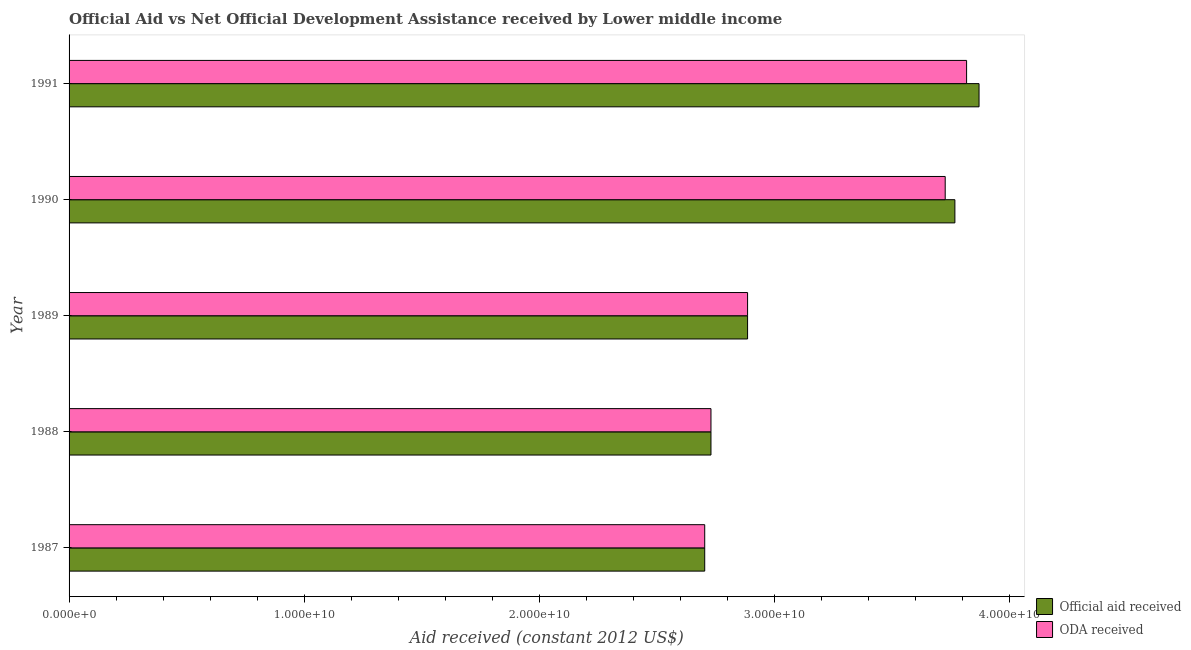How many different coloured bars are there?
Keep it short and to the point. 2. How many groups of bars are there?
Offer a terse response. 5. How many bars are there on the 1st tick from the bottom?
Your answer should be very brief. 2. What is the label of the 1st group of bars from the top?
Give a very brief answer. 1991. In how many cases, is the number of bars for a given year not equal to the number of legend labels?
Ensure brevity in your answer.  0. What is the oda received in 1989?
Your answer should be very brief. 2.89e+1. Across all years, what is the maximum official aid received?
Provide a short and direct response. 3.87e+1. Across all years, what is the minimum official aid received?
Your answer should be very brief. 2.70e+1. In which year was the oda received maximum?
Offer a very short reply. 1991. In which year was the official aid received minimum?
Provide a short and direct response. 1987. What is the total oda received in the graph?
Give a very brief answer. 1.59e+11. What is the difference between the oda received in 1987 and that in 1990?
Your answer should be compact. -1.02e+1. What is the difference between the official aid received in 1990 and the oda received in 1991?
Your answer should be very brief. -4.98e+08. What is the average oda received per year?
Your response must be concise. 3.17e+1. In the year 1988, what is the difference between the official aid received and oda received?
Make the answer very short. 0. What is the ratio of the oda received in 1989 to that in 1990?
Your response must be concise. 0.77. Is the official aid received in 1989 less than that in 1990?
Offer a very short reply. Yes. What is the difference between the highest and the second highest oda received?
Give a very brief answer. 9.10e+08. What is the difference between the highest and the lowest official aid received?
Make the answer very short. 1.17e+1. What does the 2nd bar from the top in 1990 represents?
Your response must be concise. Official aid received. What does the 2nd bar from the bottom in 1989 represents?
Make the answer very short. ODA received. Are all the bars in the graph horizontal?
Ensure brevity in your answer.  Yes. How many years are there in the graph?
Give a very brief answer. 5. What is the difference between two consecutive major ticks on the X-axis?
Your answer should be compact. 1.00e+1. Are the values on the major ticks of X-axis written in scientific E-notation?
Make the answer very short. Yes. Does the graph contain any zero values?
Give a very brief answer. No. How many legend labels are there?
Provide a succinct answer. 2. What is the title of the graph?
Your answer should be compact. Official Aid vs Net Official Development Assistance received by Lower middle income . What is the label or title of the X-axis?
Your answer should be very brief. Aid received (constant 2012 US$). What is the label or title of the Y-axis?
Make the answer very short. Year. What is the Aid received (constant 2012 US$) of Official aid received in 1987?
Ensure brevity in your answer.  2.70e+1. What is the Aid received (constant 2012 US$) in ODA received in 1987?
Your answer should be compact. 2.70e+1. What is the Aid received (constant 2012 US$) of Official aid received in 1988?
Your answer should be compact. 2.73e+1. What is the Aid received (constant 2012 US$) in ODA received in 1988?
Ensure brevity in your answer.  2.73e+1. What is the Aid received (constant 2012 US$) of Official aid received in 1989?
Provide a short and direct response. 2.89e+1. What is the Aid received (constant 2012 US$) in ODA received in 1989?
Your answer should be very brief. 2.89e+1. What is the Aid received (constant 2012 US$) in Official aid received in 1990?
Your answer should be very brief. 3.77e+1. What is the Aid received (constant 2012 US$) in ODA received in 1990?
Provide a short and direct response. 3.73e+1. What is the Aid received (constant 2012 US$) of Official aid received in 1991?
Offer a terse response. 3.87e+1. What is the Aid received (constant 2012 US$) in ODA received in 1991?
Offer a very short reply. 3.82e+1. Across all years, what is the maximum Aid received (constant 2012 US$) of Official aid received?
Give a very brief answer. 3.87e+1. Across all years, what is the maximum Aid received (constant 2012 US$) of ODA received?
Make the answer very short. 3.82e+1. Across all years, what is the minimum Aid received (constant 2012 US$) of Official aid received?
Your answer should be very brief. 2.70e+1. Across all years, what is the minimum Aid received (constant 2012 US$) in ODA received?
Provide a succinct answer. 2.70e+1. What is the total Aid received (constant 2012 US$) in Official aid received in the graph?
Provide a succinct answer. 1.60e+11. What is the total Aid received (constant 2012 US$) of ODA received in the graph?
Your response must be concise. 1.59e+11. What is the difference between the Aid received (constant 2012 US$) in Official aid received in 1987 and that in 1988?
Offer a terse response. -2.65e+08. What is the difference between the Aid received (constant 2012 US$) of ODA received in 1987 and that in 1988?
Your response must be concise. -2.65e+08. What is the difference between the Aid received (constant 2012 US$) of Official aid received in 1987 and that in 1989?
Give a very brief answer. -1.82e+09. What is the difference between the Aid received (constant 2012 US$) in ODA received in 1987 and that in 1989?
Offer a terse response. -1.82e+09. What is the difference between the Aid received (constant 2012 US$) in Official aid received in 1987 and that in 1990?
Make the answer very short. -1.06e+1. What is the difference between the Aid received (constant 2012 US$) of ODA received in 1987 and that in 1990?
Make the answer very short. -1.02e+1. What is the difference between the Aid received (constant 2012 US$) of Official aid received in 1987 and that in 1991?
Keep it short and to the point. -1.17e+1. What is the difference between the Aid received (constant 2012 US$) in ODA received in 1987 and that in 1991?
Offer a terse response. -1.11e+1. What is the difference between the Aid received (constant 2012 US$) in Official aid received in 1988 and that in 1989?
Offer a very short reply. -1.56e+09. What is the difference between the Aid received (constant 2012 US$) in ODA received in 1988 and that in 1989?
Provide a succinct answer. -1.56e+09. What is the difference between the Aid received (constant 2012 US$) of Official aid received in 1988 and that in 1990?
Offer a terse response. -1.04e+1. What is the difference between the Aid received (constant 2012 US$) in ODA received in 1988 and that in 1990?
Provide a short and direct response. -9.97e+09. What is the difference between the Aid received (constant 2012 US$) in Official aid received in 1988 and that in 1991?
Keep it short and to the point. -1.14e+1. What is the difference between the Aid received (constant 2012 US$) of ODA received in 1988 and that in 1991?
Offer a terse response. -1.09e+1. What is the difference between the Aid received (constant 2012 US$) of Official aid received in 1989 and that in 1990?
Ensure brevity in your answer.  -8.82e+09. What is the difference between the Aid received (constant 2012 US$) of ODA received in 1989 and that in 1990?
Give a very brief answer. -8.41e+09. What is the difference between the Aid received (constant 2012 US$) of Official aid received in 1989 and that in 1991?
Ensure brevity in your answer.  -9.85e+09. What is the difference between the Aid received (constant 2012 US$) in ODA received in 1989 and that in 1991?
Your answer should be very brief. -9.32e+09. What is the difference between the Aid received (constant 2012 US$) in Official aid received in 1990 and that in 1991?
Your answer should be compact. -1.03e+09. What is the difference between the Aid received (constant 2012 US$) of ODA received in 1990 and that in 1991?
Provide a succinct answer. -9.10e+08. What is the difference between the Aid received (constant 2012 US$) in Official aid received in 1987 and the Aid received (constant 2012 US$) in ODA received in 1988?
Offer a very short reply. -2.65e+08. What is the difference between the Aid received (constant 2012 US$) in Official aid received in 1987 and the Aid received (constant 2012 US$) in ODA received in 1989?
Keep it short and to the point. -1.82e+09. What is the difference between the Aid received (constant 2012 US$) in Official aid received in 1987 and the Aid received (constant 2012 US$) in ODA received in 1990?
Offer a terse response. -1.02e+1. What is the difference between the Aid received (constant 2012 US$) in Official aid received in 1987 and the Aid received (constant 2012 US$) in ODA received in 1991?
Give a very brief answer. -1.11e+1. What is the difference between the Aid received (constant 2012 US$) of Official aid received in 1988 and the Aid received (constant 2012 US$) of ODA received in 1989?
Give a very brief answer. -1.56e+09. What is the difference between the Aid received (constant 2012 US$) of Official aid received in 1988 and the Aid received (constant 2012 US$) of ODA received in 1990?
Offer a very short reply. -9.97e+09. What is the difference between the Aid received (constant 2012 US$) in Official aid received in 1988 and the Aid received (constant 2012 US$) in ODA received in 1991?
Ensure brevity in your answer.  -1.09e+1. What is the difference between the Aid received (constant 2012 US$) in Official aid received in 1989 and the Aid received (constant 2012 US$) in ODA received in 1990?
Your answer should be compact. -8.41e+09. What is the difference between the Aid received (constant 2012 US$) of Official aid received in 1989 and the Aid received (constant 2012 US$) of ODA received in 1991?
Keep it short and to the point. -9.32e+09. What is the difference between the Aid received (constant 2012 US$) in Official aid received in 1990 and the Aid received (constant 2012 US$) in ODA received in 1991?
Provide a succinct answer. -4.98e+08. What is the average Aid received (constant 2012 US$) in Official aid received per year?
Ensure brevity in your answer.  3.19e+1. What is the average Aid received (constant 2012 US$) in ODA received per year?
Offer a very short reply. 3.17e+1. In the year 1990, what is the difference between the Aid received (constant 2012 US$) in Official aid received and Aid received (constant 2012 US$) in ODA received?
Provide a succinct answer. 4.12e+08. In the year 1991, what is the difference between the Aid received (constant 2012 US$) of Official aid received and Aid received (constant 2012 US$) of ODA received?
Your answer should be compact. 5.30e+08. What is the ratio of the Aid received (constant 2012 US$) in Official aid received in 1987 to that in 1988?
Your response must be concise. 0.99. What is the ratio of the Aid received (constant 2012 US$) of ODA received in 1987 to that in 1988?
Offer a terse response. 0.99. What is the ratio of the Aid received (constant 2012 US$) of Official aid received in 1987 to that in 1989?
Make the answer very short. 0.94. What is the ratio of the Aid received (constant 2012 US$) in ODA received in 1987 to that in 1989?
Keep it short and to the point. 0.94. What is the ratio of the Aid received (constant 2012 US$) in Official aid received in 1987 to that in 1990?
Provide a short and direct response. 0.72. What is the ratio of the Aid received (constant 2012 US$) in ODA received in 1987 to that in 1990?
Offer a terse response. 0.73. What is the ratio of the Aid received (constant 2012 US$) of Official aid received in 1987 to that in 1991?
Offer a terse response. 0.7. What is the ratio of the Aid received (constant 2012 US$) of ODA received in 1987 to that in 1991?
Your response must be concise. 0.71. What is the ratio of the Aid received (constant 2012 US$) in Official aid received in 1988 to that in 1989?
Provide a succinct answer. 0.95. What is the ratio of the Aid received (constant 2012 US$) in ODA received in 1988 to that in 1989?
Make the answer very short. 0.95. What is the ratio of the Aid received (constant 2012 US$) of Official aid received in 1988 to that in 1990?
Ensure brevity in your answer.  0.72. What is the ratio of the Aid received (constant 2012 US$) in ODA received in 1988 to that in 1990?
Offer a very short reply. 0.73. What is the ratio of the Aid received (constant 2012 US$) of Official aid received in 1988 to that in 1991?
Your answer should be compact. 0.71. What is the ratio of the Aid received (constant 2012 US$) in ODA received in 1988 to that in 1991?
Keep it short and to the point. 0.72. What is the ratio of the Aid received (constant 2012 US$) in Official aid received in 1989 to that in 1990?
Provide a succinct answer. 0.77. What is the ratio of the Aid received (constant 2012 US$) of ODA received in 1989 to that in 1990?
Offer a very short reply. 0.77. What is the ratio of the Aid received (constant 2012 US$) of Official aid received in 1989 to that in 1991?
Your answer should be very brief. 0.75. What is the ratio of the Aid received (constant 2012 US$) of ODA received in 1989 to that in 1991?
Offer a very short reply. 0.76. What is the ratio of the Aid received (constant 2012 US$) of Official aid received in 1990 to that in 1991?
Your answer should be very brief. 0.97. What is the ratio of the Aid received (constant 2012 US$) of ODA received in 1990 to that in 1991?
Make the answer very short. 0.98. What is the difference between the highest and the second highest Aid received (constant 2012 US$) in Official aid received?
Provide a succinct answer. 1.03e+09. What is the difference between the highest and the second highest Aid received (constant 2012 US$) in ODA received?
Give a very brief answer. 9.10e+08. What is the difference between the highest and the lowest Aid received (constant 2012 US$) in Official aid received?
Keep it short and to the point. 1.17e+1. What is the difference between the highest and the lowest Aid received (constant 2012 US$) in ODA received?
Offer a very short reply. 1.11e+1. 